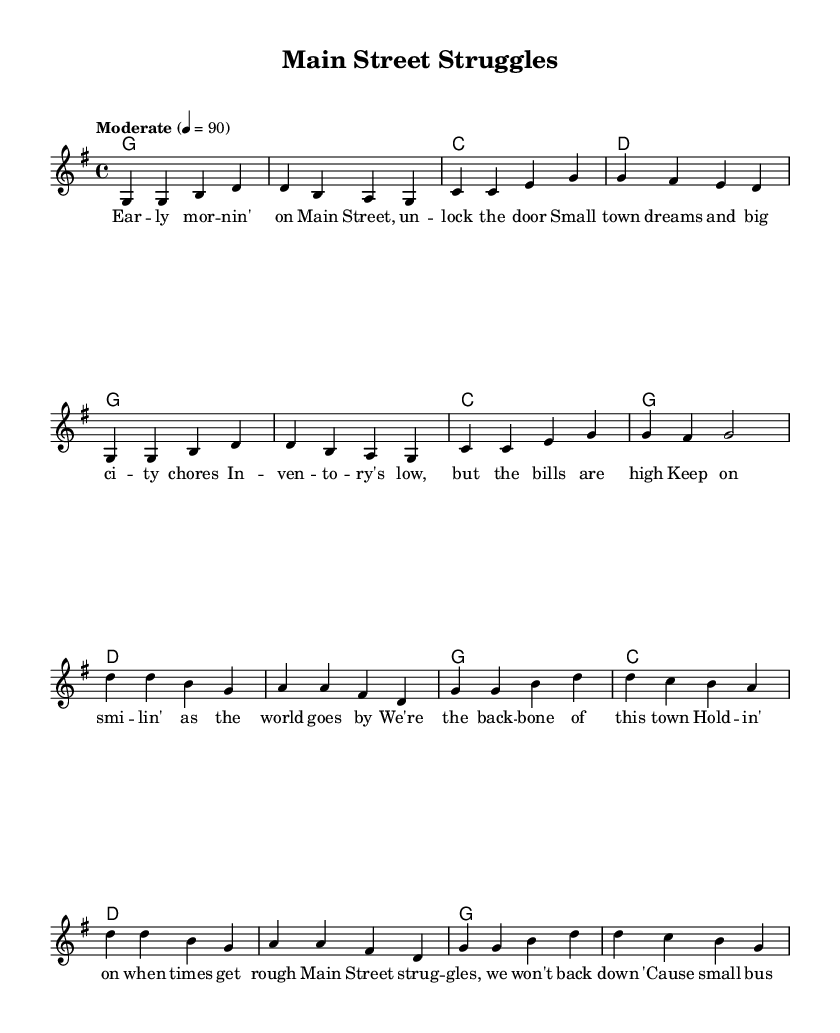What is the key signature of this music? The key signature is G major, which has one sharp (F#).
Answer: G major What is the time signature of this music? The time signature is 4/4, which indicates four beats per measure.
Answer: 4/4 What is the tempo indication for this piece? The tempo indication is "Moderate" with a speed of 90 beats per minute.
Answer: Moderate, 90 How many lines are in the melody part? The melody consists of two sections, the verse and chorus, which combined have eight lines.
Answer: Eight lines What is the main theme of the lyrics? The main theme revolves around the challenges faced by small-town business owners.
Answer: Small-town business struggles How does the chorus reflect resilience? The chorus emphasizes holding on and not backing down despite tough times, symbolizing resilience in the face of adversity.
Answer: Emphasizes resilience Which chord follows the second line of the verse? The chord that follows the second line of the verse is C major.
Answer: C major 